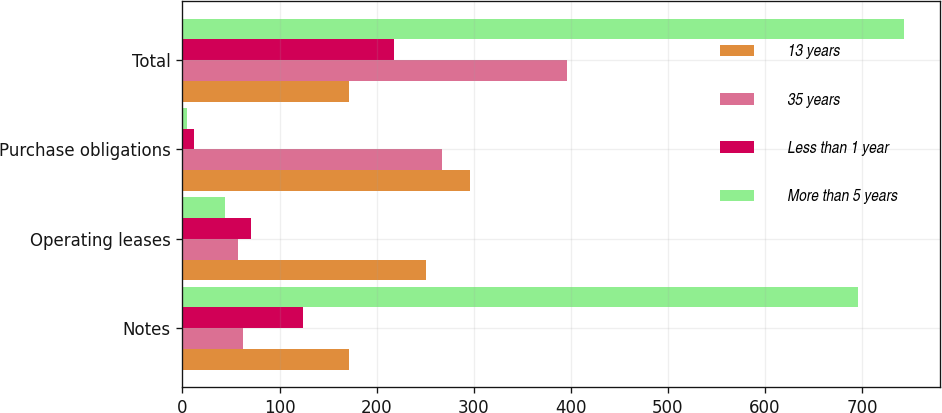Convert chart to OTSL. <chart><loc_0><loc_0><loc_500><loc_500><stacked_bar_chart><ecel><fcel>Notes<fcel>Operating leases<fcel>Purchase obligations<fcel>Total<nl><fcel>13 years<fcel>171<fcel>251.2<fcel>296.1<fcel>171<nl><fcel>35 years<fcel>62.3<fcel>56.8<fcel>267.3<fcel>396.3<nl><fcel>Less than 1 year<fcel>124.5<fcel>70.6<fcel>11.6<fcel>217.5<nl><fcel>More than 5 years<fcel>695.3<fcel>43.9<fcel>4.2<fcel>743.4<nl></chart> 